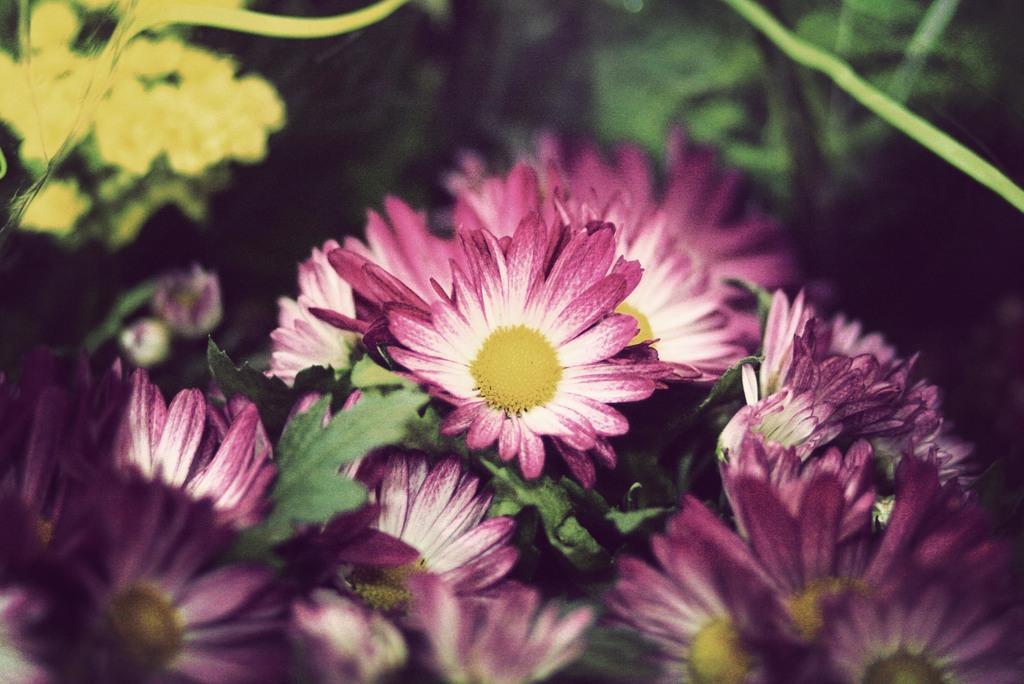How would you summarize this image in a sentence or two? As we can see in the image there are plants and flowers. 